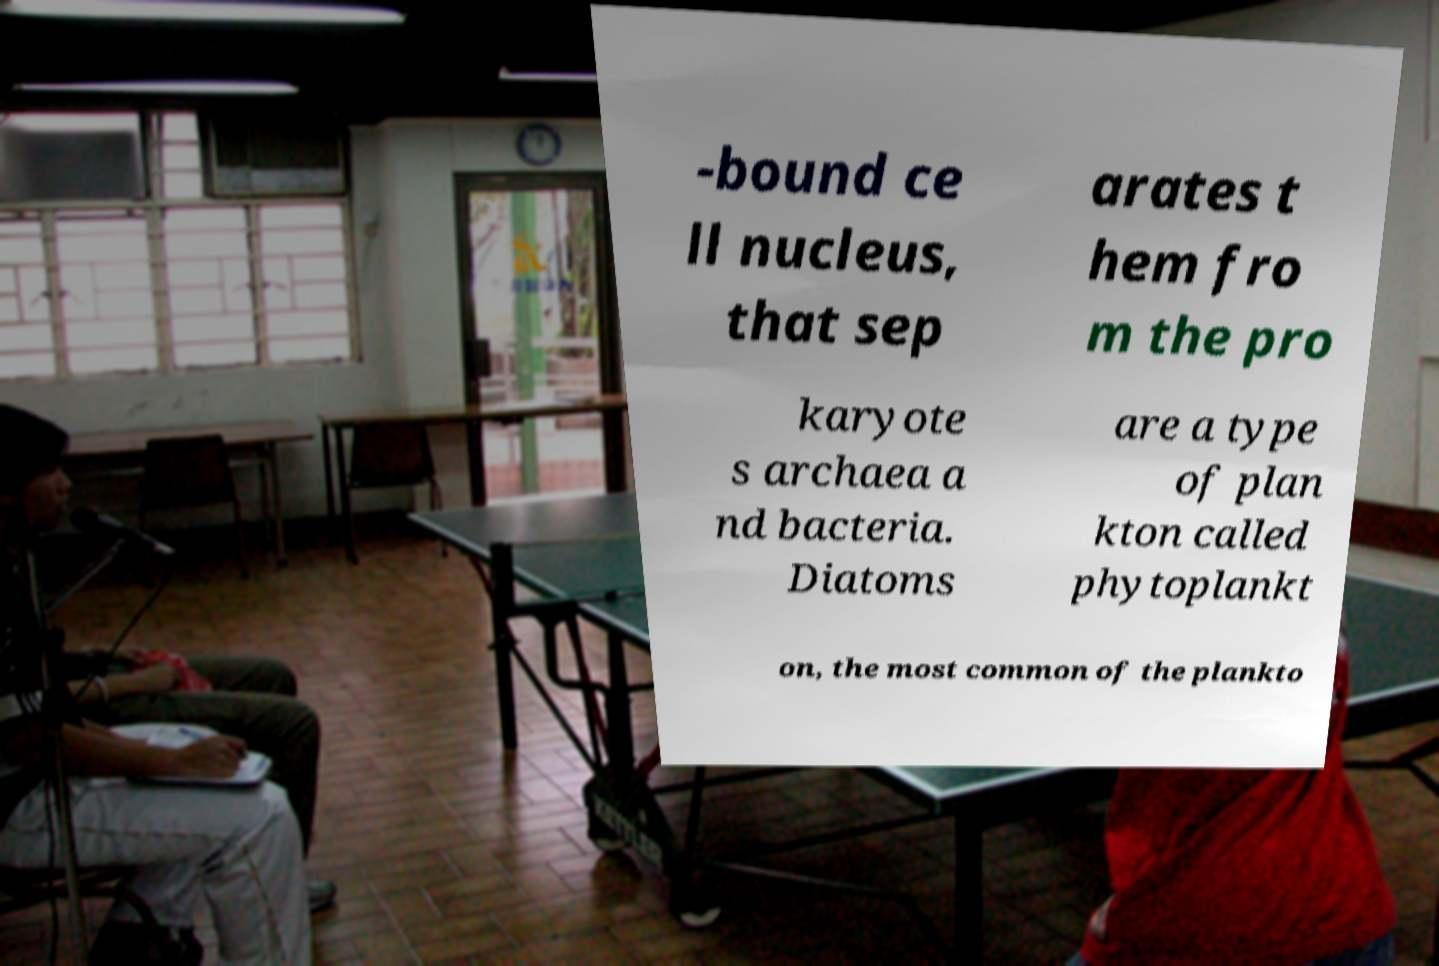For documentation purposes, I need the text within this image transcribed. Could you provide that? -bound ce ll nucleus, that sep arates t hem fro m the pro karyote s archaea a nd bacteria. Diatoms are a type of plan kton called phytoplankt on, the most common of the plankto 